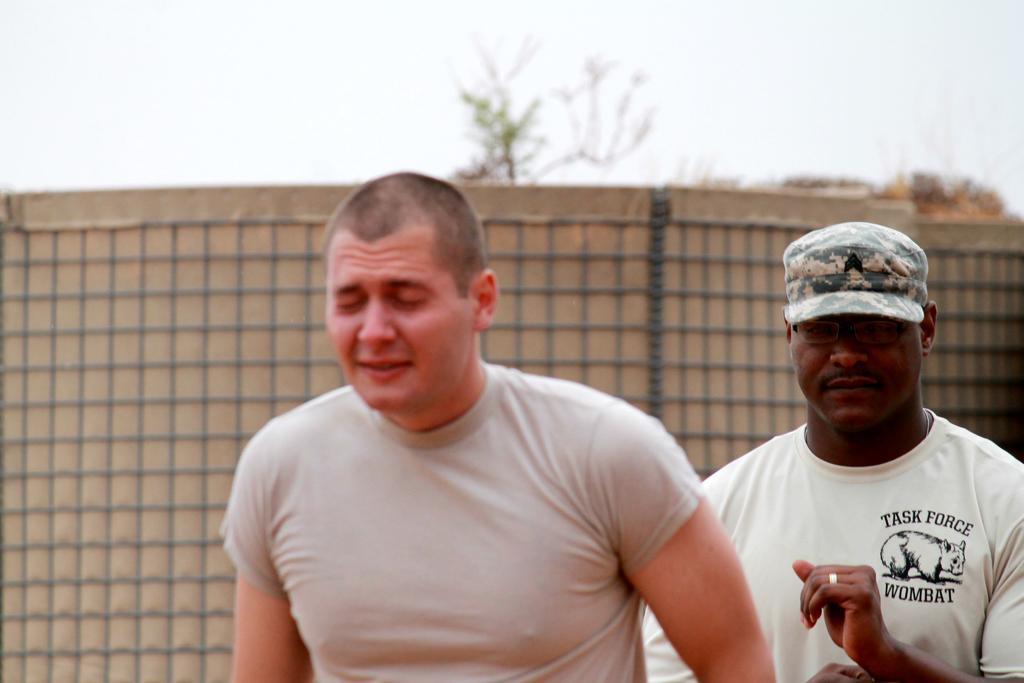In one or two sentences, can you explain what this image depicts? In the foreground of the picture there is a person. On the right there is a person wearing cap. In the background there are trees, wall, sky and net. 